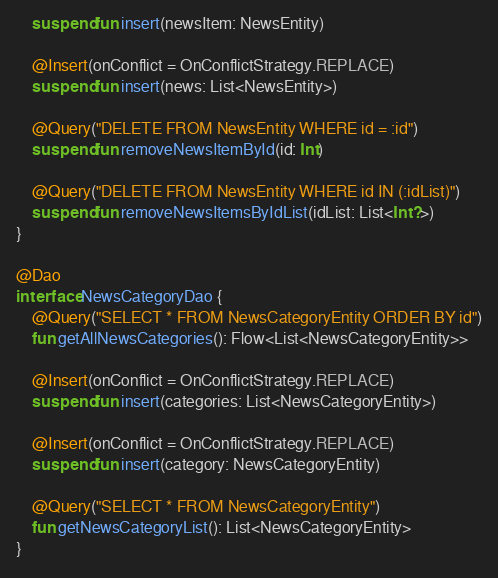Convert code to text. <code><loc_0><loc_0><loc_500><loc_500><_Kotlin_>    suspend fun insert(newsItem: NewsEntity)

    @Insert(onConflict = OnConflictStrategy.REPLACE)
    suspend fun insert(news: List<NewsEntity>)

    @Query("DELETE FROM NewsEntity WHERE id = :id")
    suspend fun removeNewsItemById(id: Int)

    @Query("DELETE FROM NewsEntity WHERE id IN (:idList)")
    suspend fun removeNewsItemsByIdList(idList: List<Int?>)
}

@Dao
interface NewsCategoryDao {
    @Query("SELECT * FROM NewsCategoryEntity ORDER BY id")
    fun getAllNewsCategories(): Flow<List<NewsCategoryEntity>>

    @Insert(onConflict = OnConflictStrategy.REPLACE)
    suspend fun insert(categories: List<NewsCategoryEntity>)

    @Insert(onConflict = OnConflictStrategy.REPLACE)
    suspend fun insert(category: NewsCategoryEntity)

    @Query("SELECT * FROM NewsCategoryEntity")
    fun getNewsCategoryList(): List<NewsCategoryEntity>
}
</code> 